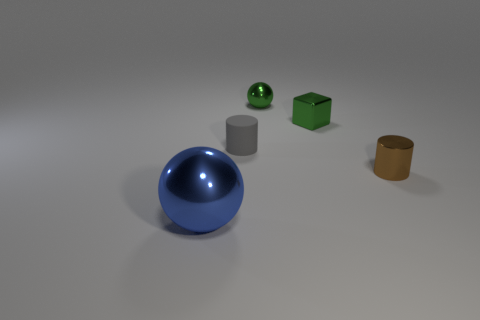Is there anything else that has the same material as the tiny gray cylinder?
Offer a very short reply. No. Is there any other thing that is the same size as the blue thing?
Keep it short and to the point. No. What number of objects are either metallic balls in front of the shiny block or rubber cylinders?
Provide a succinct answer. 2. How many other objects are there of the same material as the small brown cylinder?
Make the answer very short. 3. There is a shiny object that is the same color as the tiny metallic block; what shape is it?
Make the answer very short. Sphere. There is a cylinder behind the brown object; what size is it?
Ensure brevity in your answer.  Small. What is the shape of the brown thing that is made of the same material as the green block?
Give a very brief answer. Cylinder. Is the green block made of the same material as the small cylinder on the left side of the brown shiny object?
Make the answer very short. No. Is the shape of the thing that is in front of the small brown metallic thing the same as  the rubber thing?
Offer a very short reply. No. What material is the other tiny object that is the same shape as the tiny gray object?
Provide a short and direct response. Metal. 